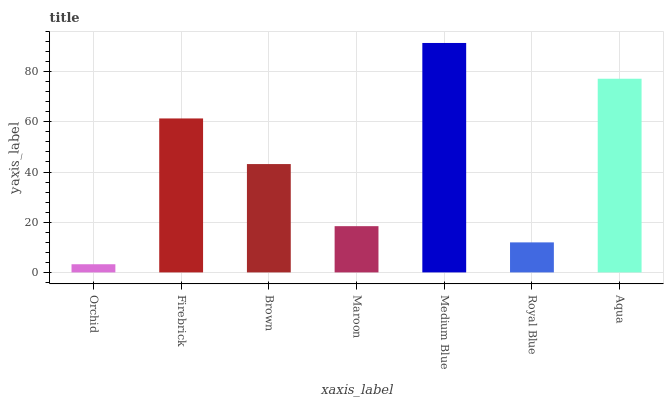Is Orchid the minimum?
Answer yes or no. Yes. Is Medium Blue the maximum?
Answer yes or no. Yes. Is Firebrick the minimum?
Answer yes or no. No. Is Firebrick the maximum?
Answer yes or no. No. Is Firebrick greater than Orchid?
Answer yes or no. Yes. Is Orchid less than Firebrick?
Answer yes or no. Yes. Is Orchid greater than Firebrick?
Answer yes or no. No. Is Firebrick less than Orchid?
Answer yes or no. No. Is Brown the high median?
Answer yes or no. Yes. Is Brown the low median?
Answer yes or no. Yes. Is Maroon the high median?
Answer yes or no. No. Is Firebrick the low median?
Answer yes or no. No. 